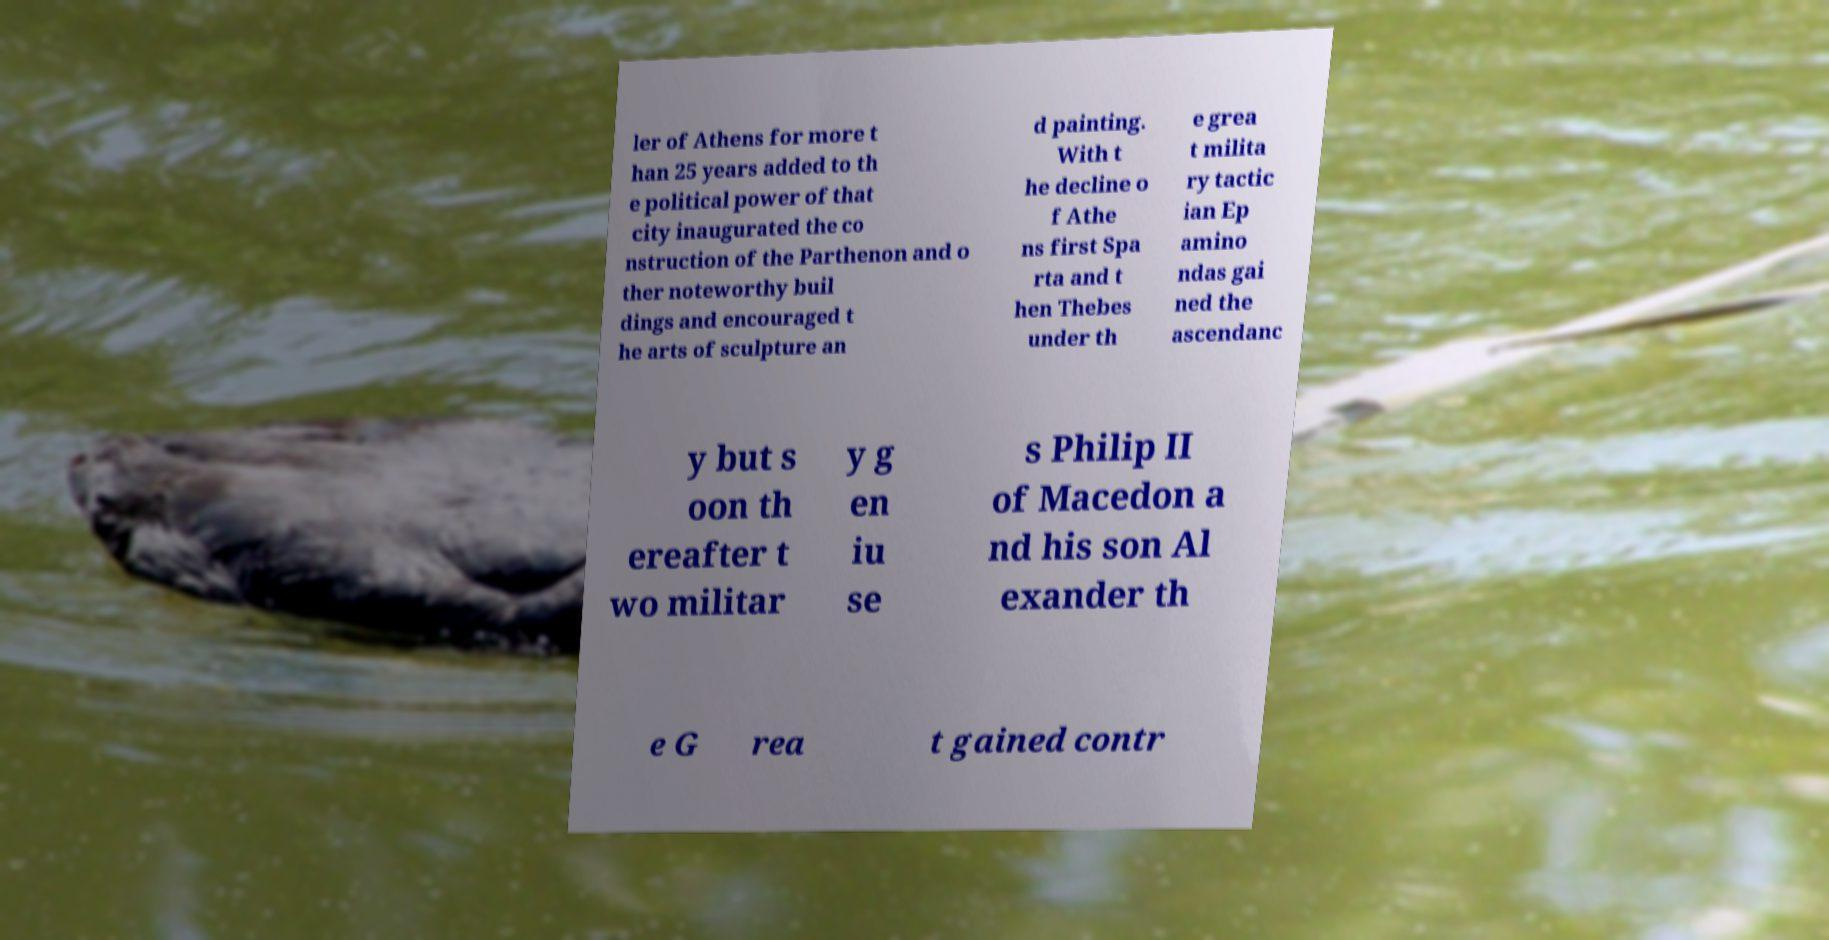Can you read and provide the text displayed in the image?This photo seems to have some interesting text. Can you extract and type it out for me? ler of Athens for more t han 25 years added to th e political power of that city inaugurated the co nstruction of the Parthenon and o ther noteworthy buil dings and encouraged t he arts of sculpture an d painting. With t he decline o f Athe ns first Spa rta and t hen Thebes under th e grea t milita ry tactic ian Ep amino ndas gai ned the ascendanc y but s oon th ereafter t wo militar y g en iu se s Philip II of Macedon a nd his son Al exander th e G rea t gained contr 